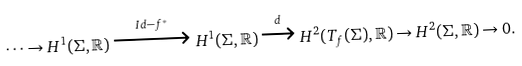<formula> <loc_0><loc_0><loc_500><loc_500>\dots \rightarrow H ^ { 1 } ( \Sigma , \mathbb { R } ) \xrightarrow { I d - f ^ { * } } H ^ { 1 } ( \Sigma , \mathbb { R } ) \xrightarrow { d } H ^ { 2 } ( T _ { f } ( \Sigma ) , \mathbb { R } ) \rightarrow H ^ { 2 } ( \Sigma , \mathbb { R } ) \rightarrow 0 .</formula> 